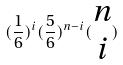Convert formula to latex. <formula><loc_0><loc_0><loc_500><loc_500>( \frac { 1 } { 6 } ) ^ { i } ( \frac { 5 } { 6 } ) ^ { n - i } ( \begin{matrix} n \\ i \end{matrix} )</formula> 